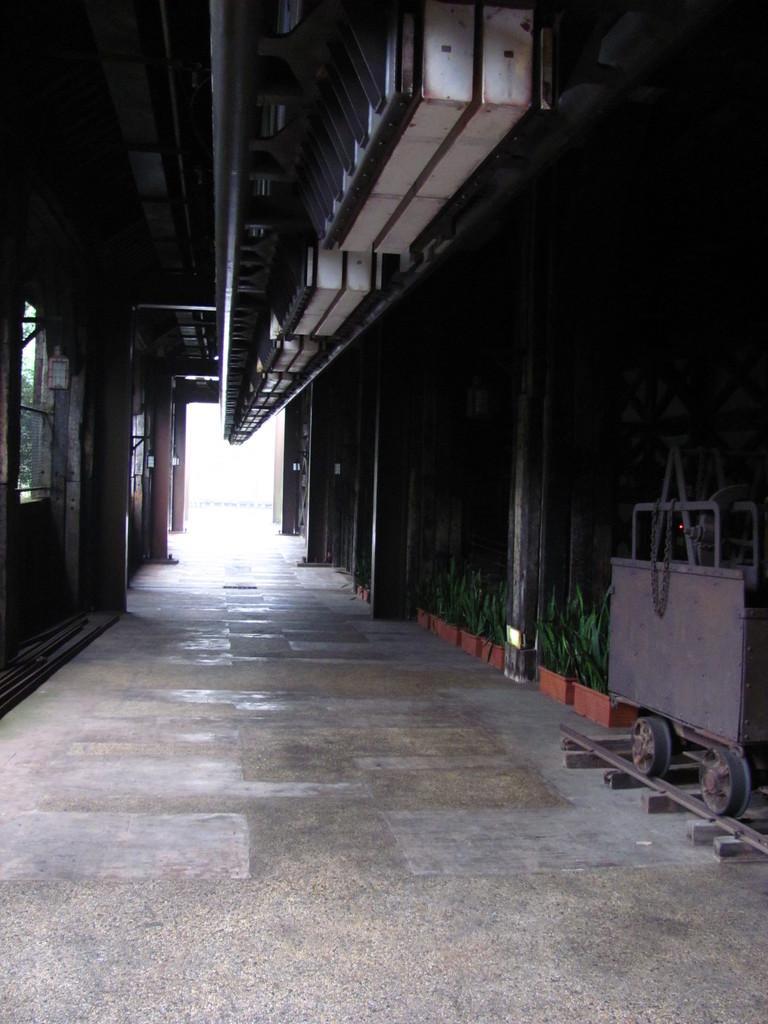How would you summarize this image in a sentence or two? In this picture we can see an inside view of a building, on the right side there are some plants, a track and a trolley, on the left side it looks like a door. 